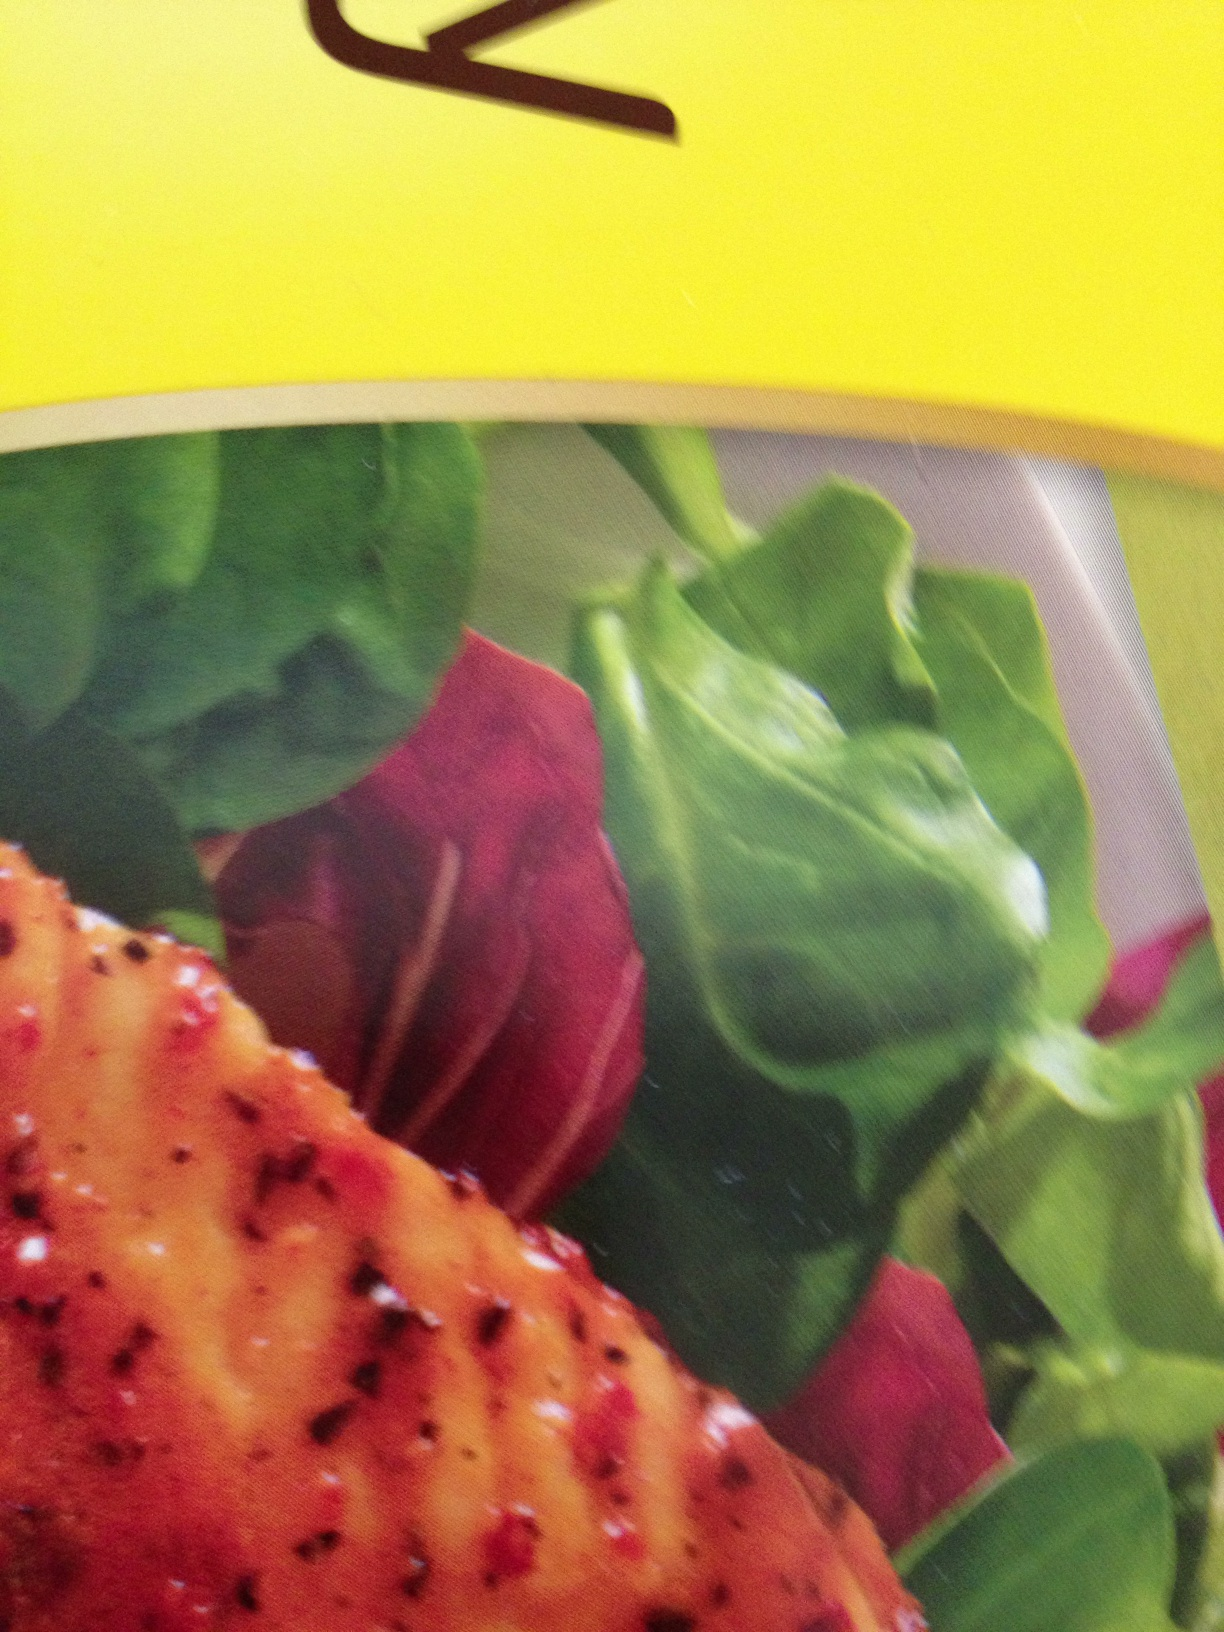what is this? This image appears to show food, potentially a dish with grilled meat or a similar item, garnished with leafy greens and some red, possibly beet slices or a similar vegetable. 